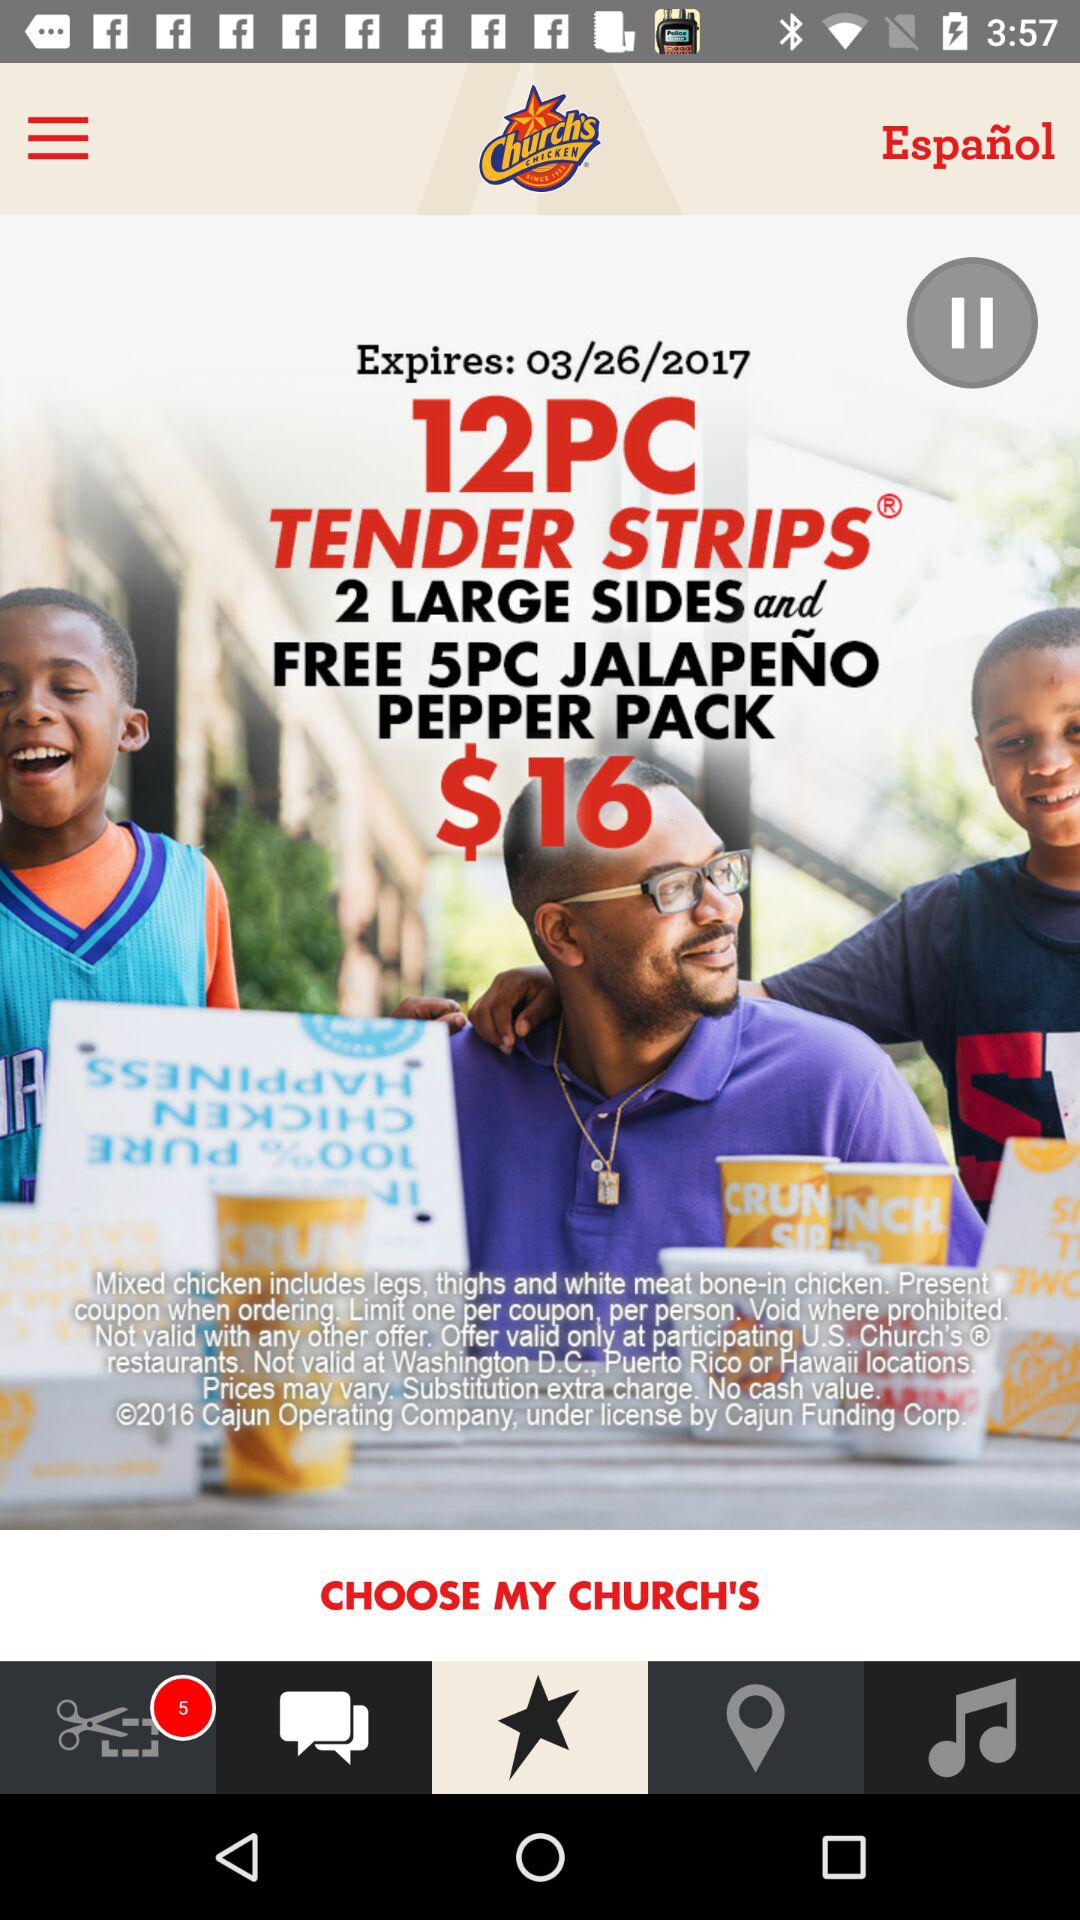What is the expiration date of the coupon? The expiration date of the coupon is March 26, 2017. 